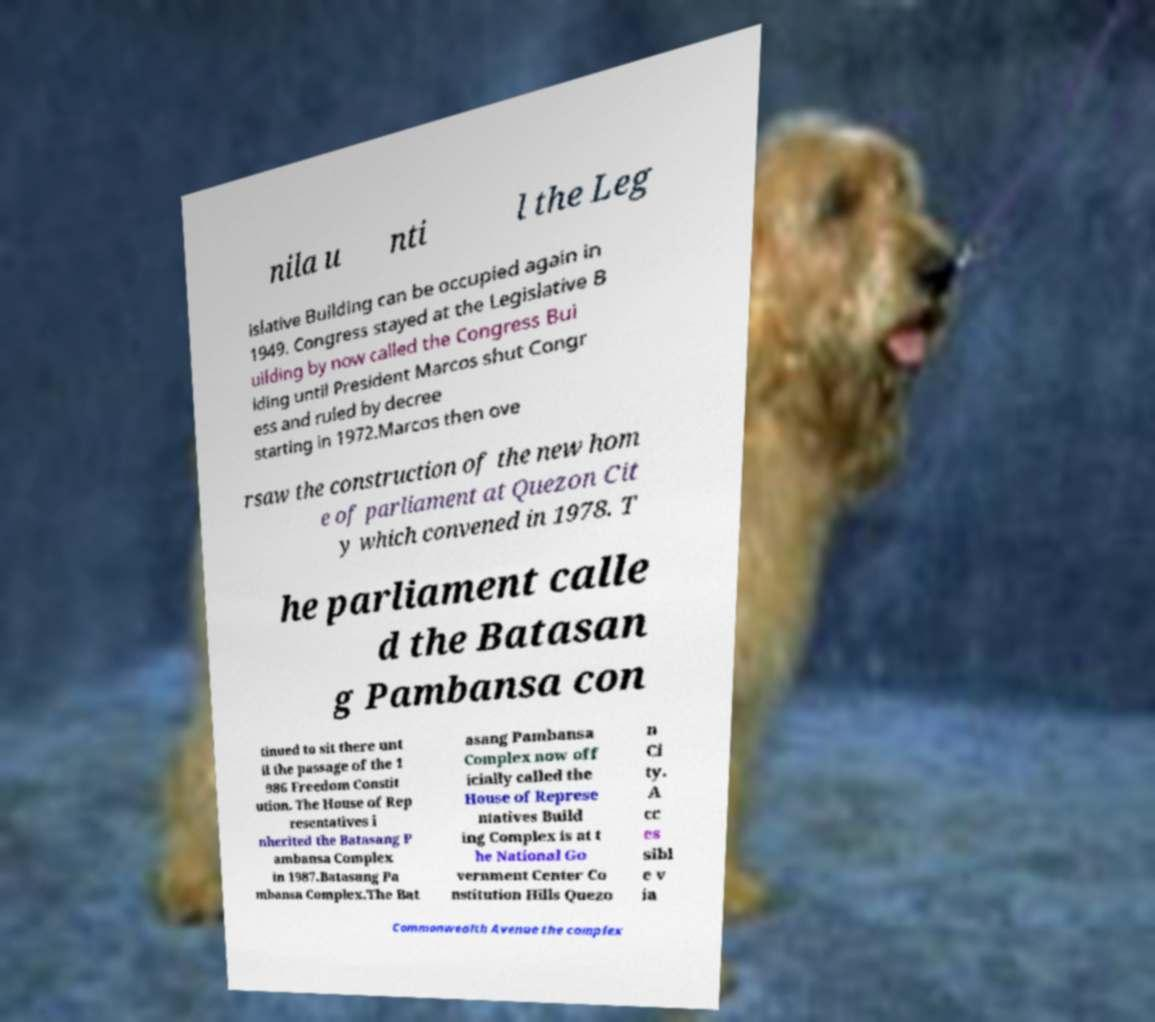For documentation purposes, I need the text within this image transcribed. Could you provide that? nila u nti l the Leg islative Building can be occupied again in 1949. Congress stayed at the Legislative B uilding by now called the Congress Bui lding until President Marcos shut Congr ess and ruled by decree starting in 1972.Marcos then ove rsaw the construction of the new hom e of parliament at Quezon Cit y which convened in 1978. T he parliament calle d the Batasan g Pambansa con tinued to sit there unt il the passage of the 1 986 Freedom Constit ution. The House of Rep resentatives i nherited the Batasang P ambansa Complex in 1987.Batasang Pa mbansa Complex.The Bat asang Pambansa Complex now off icially called the House of Represe ntatives Build ing Complex is at t he National Go vernment Center Co nstitution Hills Quezo n Ci ty. A cc es sibl e v ia Commonwealth Avenue the complex 